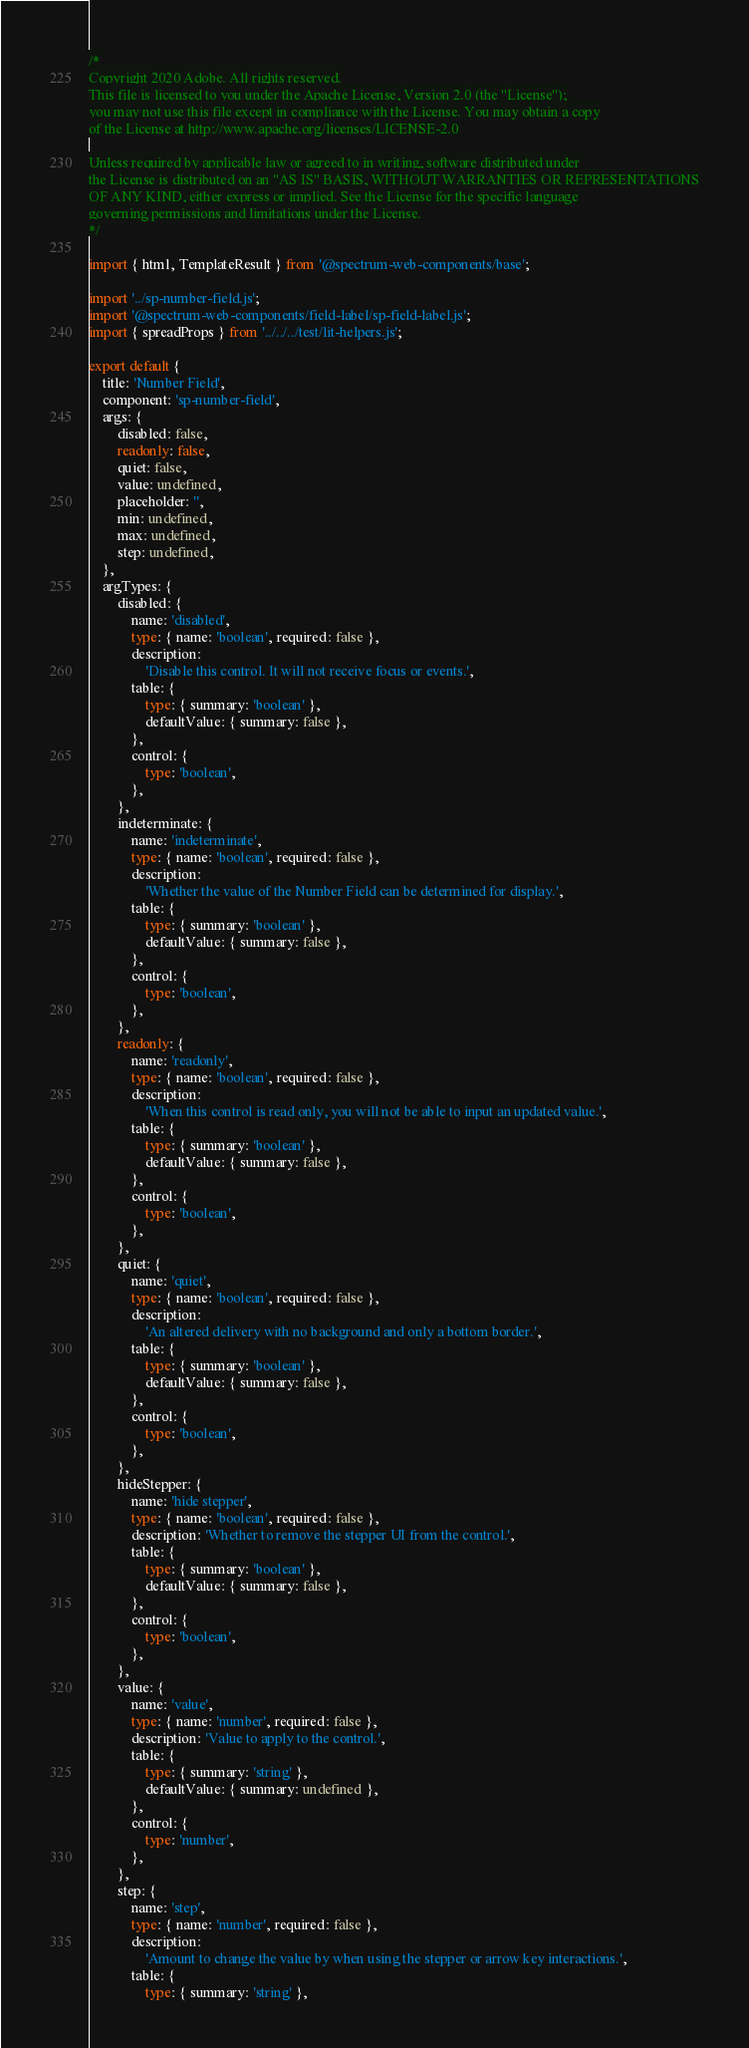<code> <loc_0><loc_0><loc_500><loc_500><_TypeScript_>/*
Copyright 2020 Adobe. All rights reserved.
This file is licensed to you under the Apache License, Version 2.0 (the "License");
you may not use this file except in compliance with the License. You may obtain a copy
of the License at http://www.apache.org/licenses/LICENSE-2.0

Unless required by applicable law or agreed to in writing, software distributed under
the License is distributed on an "AS IS" BASIS, WITHOUT WARRANTIES OR REPRESENTATIONS
OF ANY KIND, either express or implied. See the License for the specific language
governing permissions and limitations under the License.
*/

import { html, TemplateResult } from '@spectrum-web-components/base';

import '../sp-number-field.js';
import '@spectrum-web-components/field-label/sp-field-label.js';
import { spreadProps } from '../../../test/lit-helpers.js';

export default {
    title: 'Number Field',
    component: 'sp-number-field',
    args: {
        disabled: false,
        readonly: false,
        quiet: false,
        value: undefined,
        placeholder: '',
        min: undefined,
        max: undefined,
        step: undefined,
    },
    argTypes: {
        disabled: {
            name: 'disabled',
            type: { name: 'boolean', required: false },
            description:
                'Disable this control. It will not receive focus or events.',
            table: {
                type: { summary: 'boolean' },
                defaultValue: { summary: false },
            },
            control: {
                type: 'boolean',
            },
        },
        indeterminate: {
            name: 'indeterminate',
            type: { name: 'boolean', required: false },
            description:
                'Whether the value of the Number Field can be determined for display.',
            table: {
                type: { summary: 'boolean' },
                defaultValue: { summary: false },
            },
            control: {
                type: 'boolean',
            },
        },
        readonly: {
            name: 'readonly',
            type: { name: 'boolean', required: false },
            description:
                'When this control is read only, you will not be able to input an updated value.',
            table: {
                type: { summary: 'boolean' },
                defaultValue: { summary: false },
            },
            control: {
                type: 'boolean',
            },
        },
        quiet: {
            name: 'quiet',
            type: { name: 'boolean', required: false },
            description:
                'An altered delivery with no background and only a bottom border.',
            table: {
                type: { summary: 'boolean' },
                defaultValue: { summary: false },
            },
            control: {
                type: 'boolean',
            },
        },
        hideStepper: {
            name: 'hide stepper',
            type: { name: 'boolean', required: false },
            description: 'Whether to remove the stepper UI from the control.',
            table: {
                type: { summary: 'boolean' },
                defaultValue: { summary: false },
            },
            control: {
                type: 'boolean',
            },
        },
        value: {
            name: 'value',
            type: { name: 'number', required: false },
            description: 'Value to apply to the control.',
            table: {
                type: { summary: 'string' },
                defaultValue: { summary: undefined },
            },
            control: {
                type: 'number',
            },
        },
        step: {
            name: 'step',
            type: { name: 'number', required: false },
            description:
                'Amount to change the value by when using the stepper or arrow key interactions.',
            table: {
                type: { summary: 'string' },</code> 